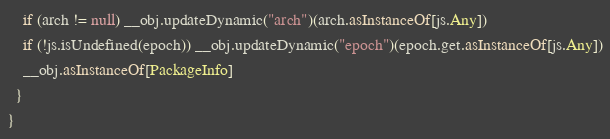<code> <loc_0><loc_0><loc_500><loc_500><_Scala_>    if (arch != null) __obj.updateDynamic("arch")(arch.asInstanceOf[js.Any])
    if (!js.isUndefined(epoch)) __obj.updateDynamic("epoch")(epoch.get.asInstanceOf[js.Any])
    __obj.asInstanceOf[PackageInfo]
  }
}

</code> 